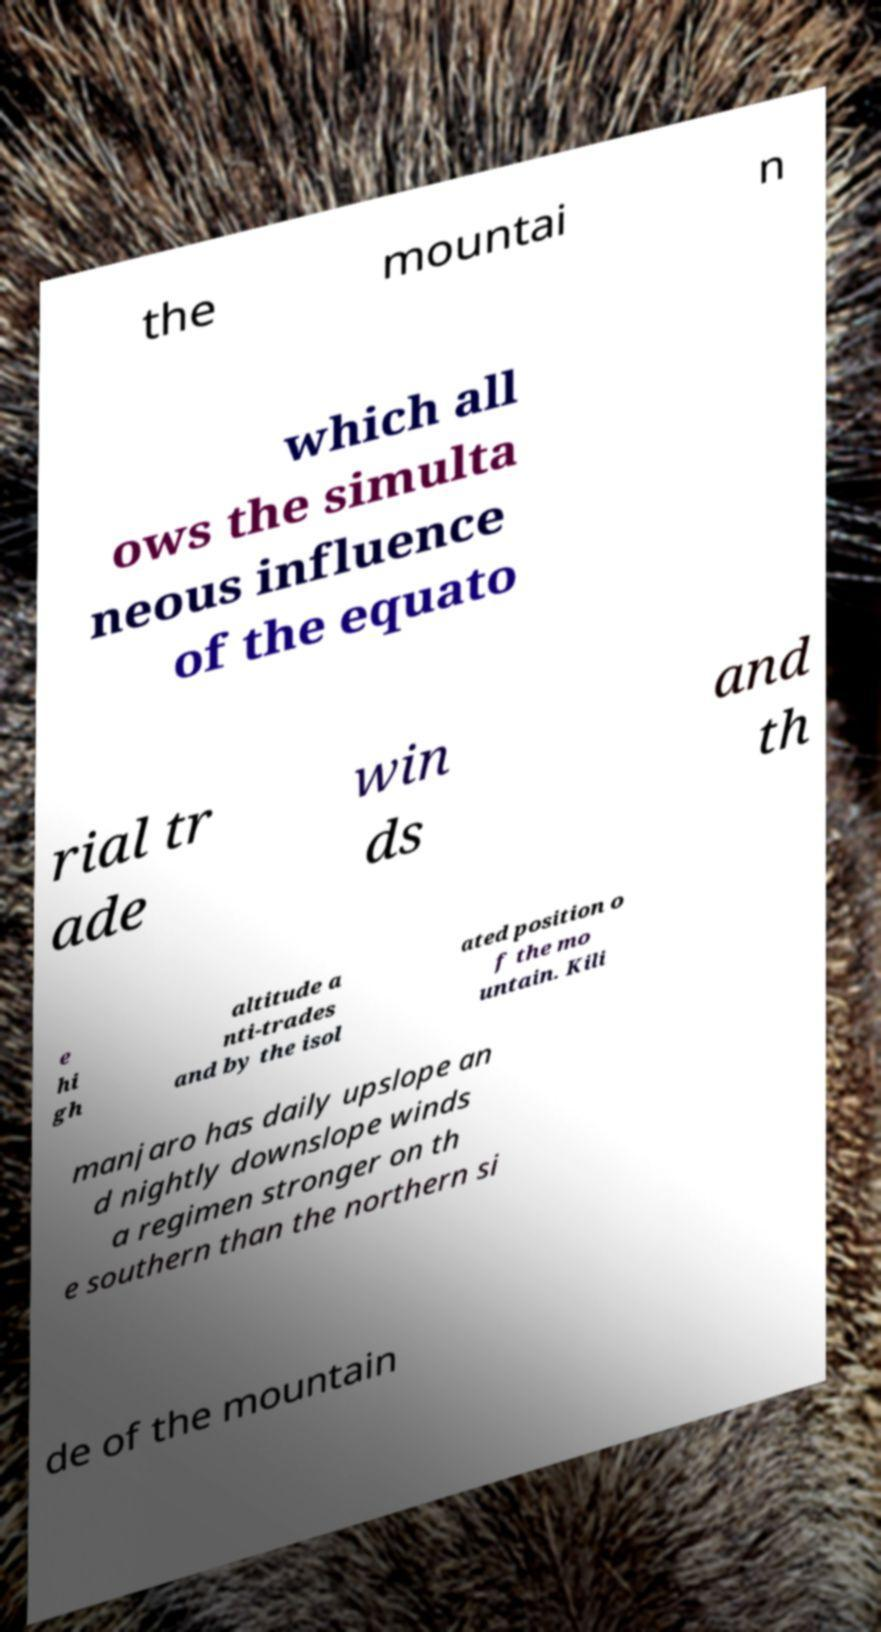Please read and relay the text visible in this image. What does it say? the mountai n which all ows the simulta neous influence of the equato rial tr ade win ds and th e hi gh altitude a nti-trades and by the isol ated position o f the mo untain. Kili manjaro has daily upslope an d nightly downslope winds a regimen stronger on th e southern than the northern si de of the mountain 